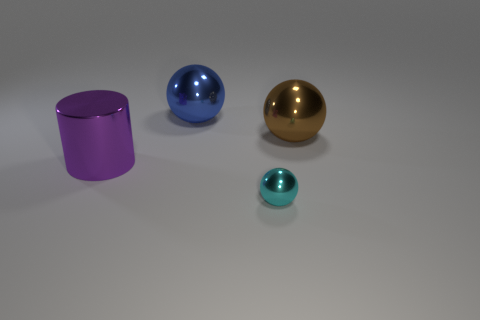How big is the shiny ball that is in front of the big brown object?
Keep it short and to the point. Small. What shape is the tiny cyan thing that is made of the same material as the cylinder?
Ensure brevity in your answer.  Sphere. Are the brown object and the large sphere that is to the left of the tiny shiny object made of the same material?
Provide a succinct answer. Yes. Is the shape of the large metallic thing to the right of the blue shiny object the same as  the purple shiny object?
Provide a succinct answer. No. What material is the other blue object that is the same shape as the tiny thing?
Keep it short and to the point. Metal. There is a brown metallic object; does it have the same shape as the purple metal thing behind the small metal ball?
Ensure brevity in your answer.  No. There is a metallic sphere that is to the left of the brown sphere and to the right of the blue shiny ball; what color is it?
Give a very brief answer. Cyan. Are there any blue matte objects?
Ensure brevity in your answer.  No. Are there the same number of big blue shiny spheres on the right side of the big blue ball and purple metal cylinders?
Keep it short and to the point. No. What number of other things are there of the same shape as the cyan metal thing?
Make the answer very short. 2. 